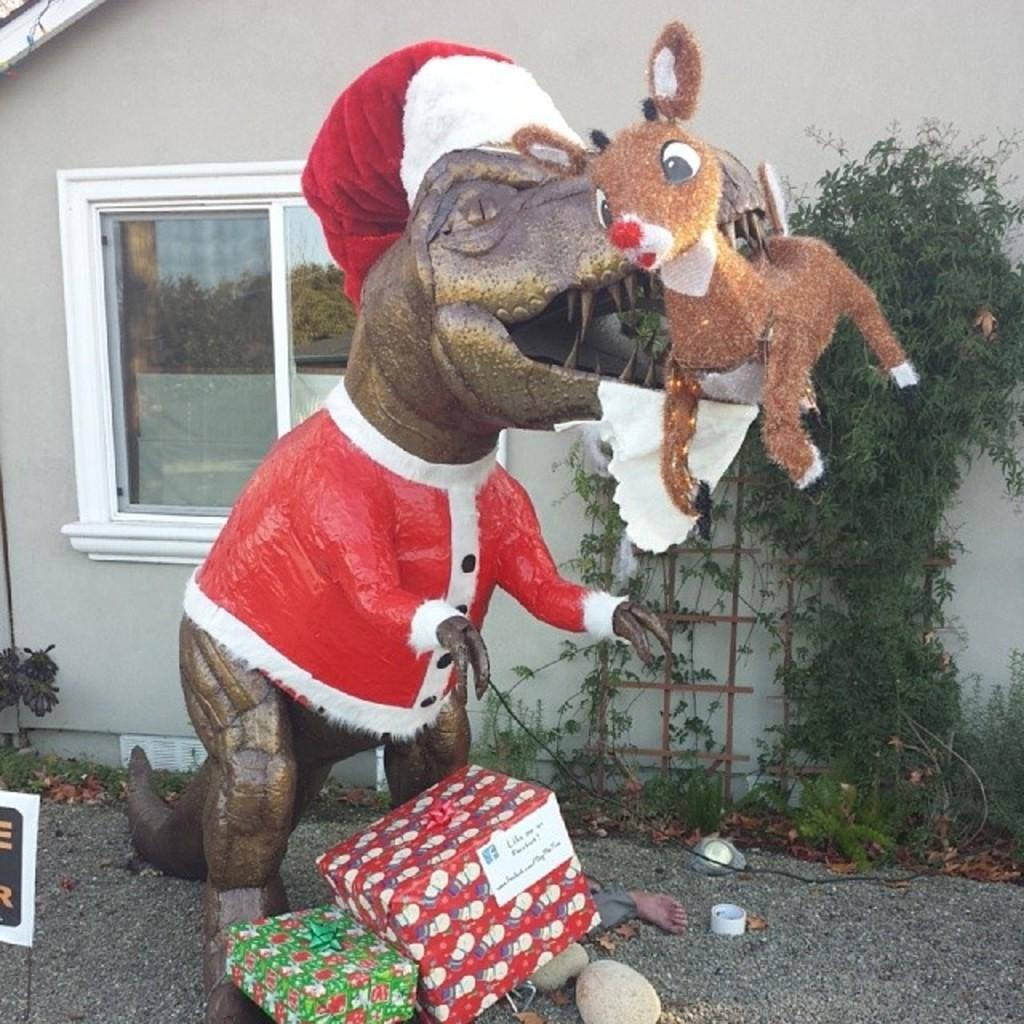Describe this image in one or two sentences. In this image, I can see the sculpture. These are the gift boxes, which are packed. I can see a person's legs. These are the rocks. This looks like a house with a window. I can see a tree. 